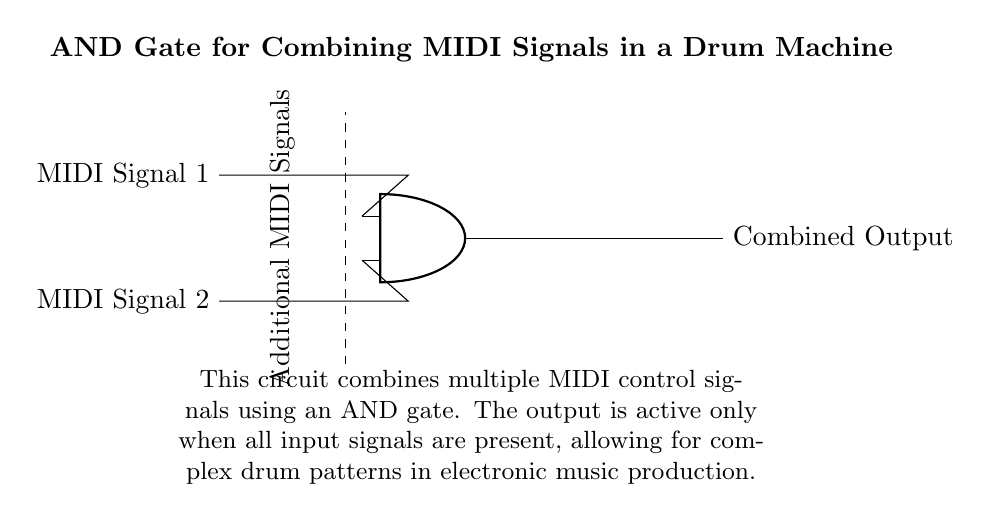What components are used in this circuit? The circuit uses an AND gate and two MIDI signal inputs. The AND gate is the primary component that combines the signals, while the MIDI signals serve as inputs.
Answer: AND gate, MIDI Signal 1, MIDI Signal 2 How many input signals does the AND gate receive? The circuit diagram clearly shows that the AND gate has two inputs indicated by the connections from MIDI Signal 1 and MIDI Signal 2. Therefore, it receives two input signals.
Answer: Two What is the output of the AND gate when both inputs are present? In an AND gate, the output is active or high only when all inputs are high. Given that both MIDI signals are connected here, the output will be combined and active, assuming both are present.
Answer: Combined Output What happens to the output if one MIDI signal is absent? If one of the MIDI input signals is absent, the AND gate will not receive all necessary inputs, which means the output will be inactive, resulting in no combined output.
Answer: Inactive Which logic function is represented by this circuit? The circuit represents the AND logic function, which is characterized by its ability to output a high signal only when all input signals are high.
Answer: AND What indicates the presence of additional MIDI signals in the circuit? The dashed line in the diagram labeled “Additional MIDI Signals” indicates that there are more signals that can be fed into the AND gate, suggesting it is designed to accommodate more inputs if needed.
Answer: Dashed line What role does the dashed line play in this circuit diagram? The dashed line represents the possibility of incorporating additional MIDI signals into the circuit. This indicates that the circuit is scalable and can expand to include more inputs as necessary.
Answer: Scalability 